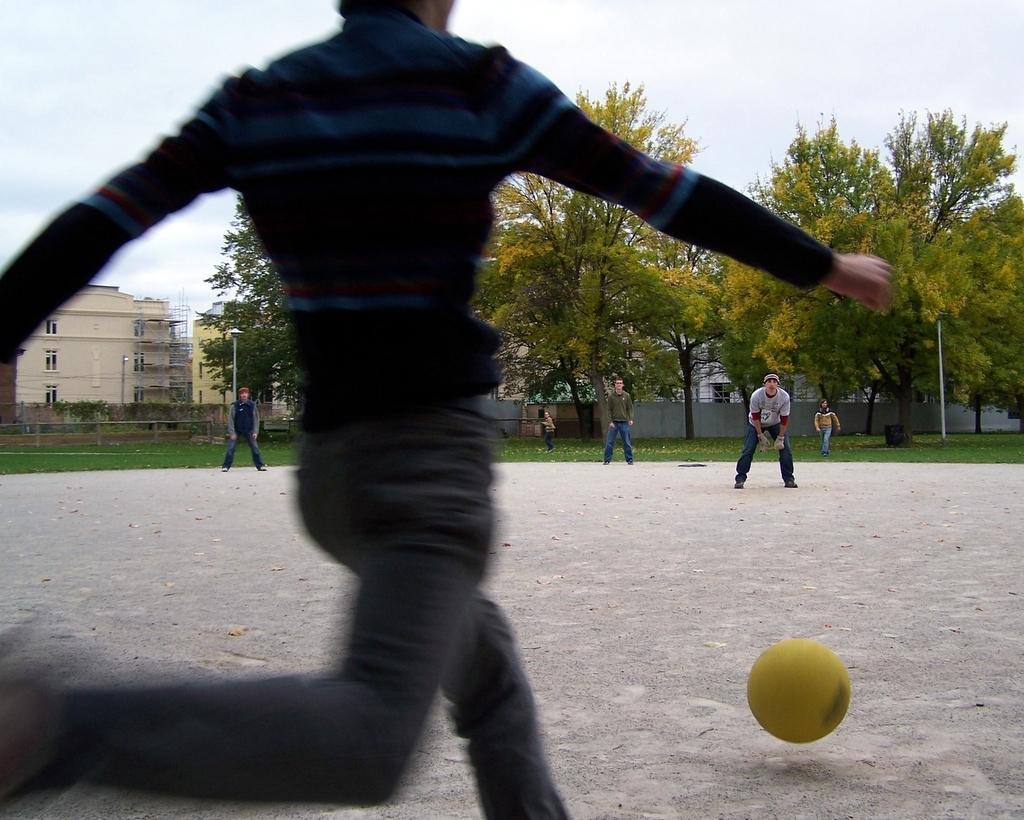Could you give a brief overview of what you see in this image? In this picture we can see a person is trying to hit a yellow ball and in front of the person there are groups of people standing. Behind the people there are poles, wall, trees, buildings and a sky. 